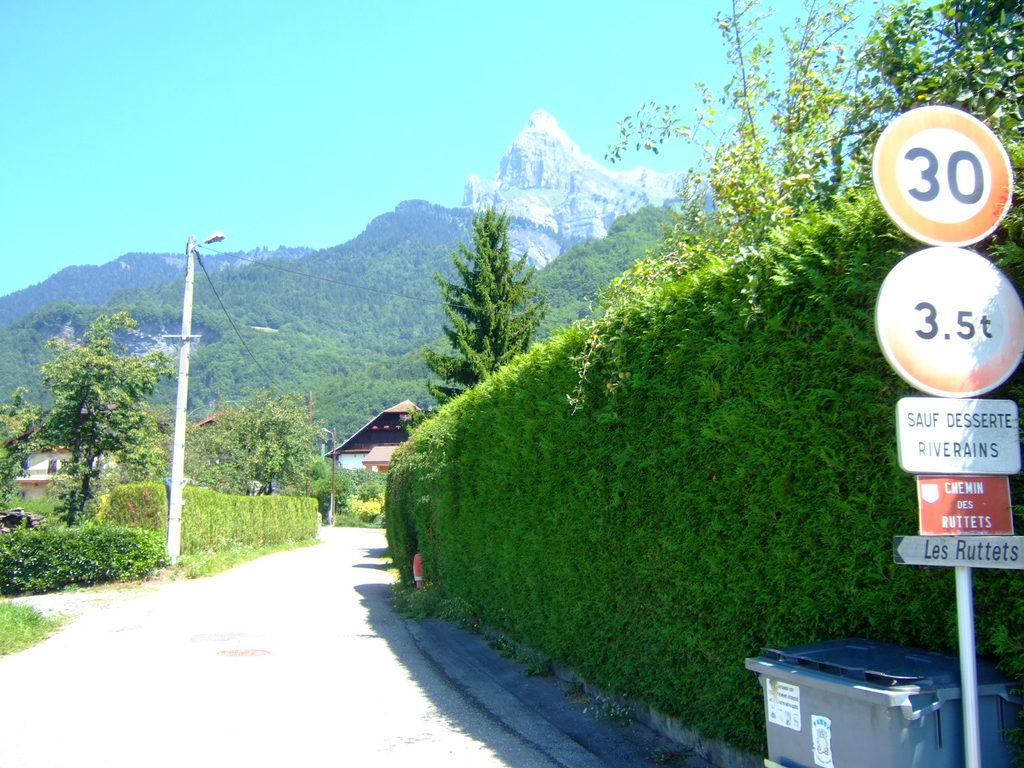<image>
Offer a succinct explanation of the picture presented. A small French road near the mountains has a speed limit of 30. 